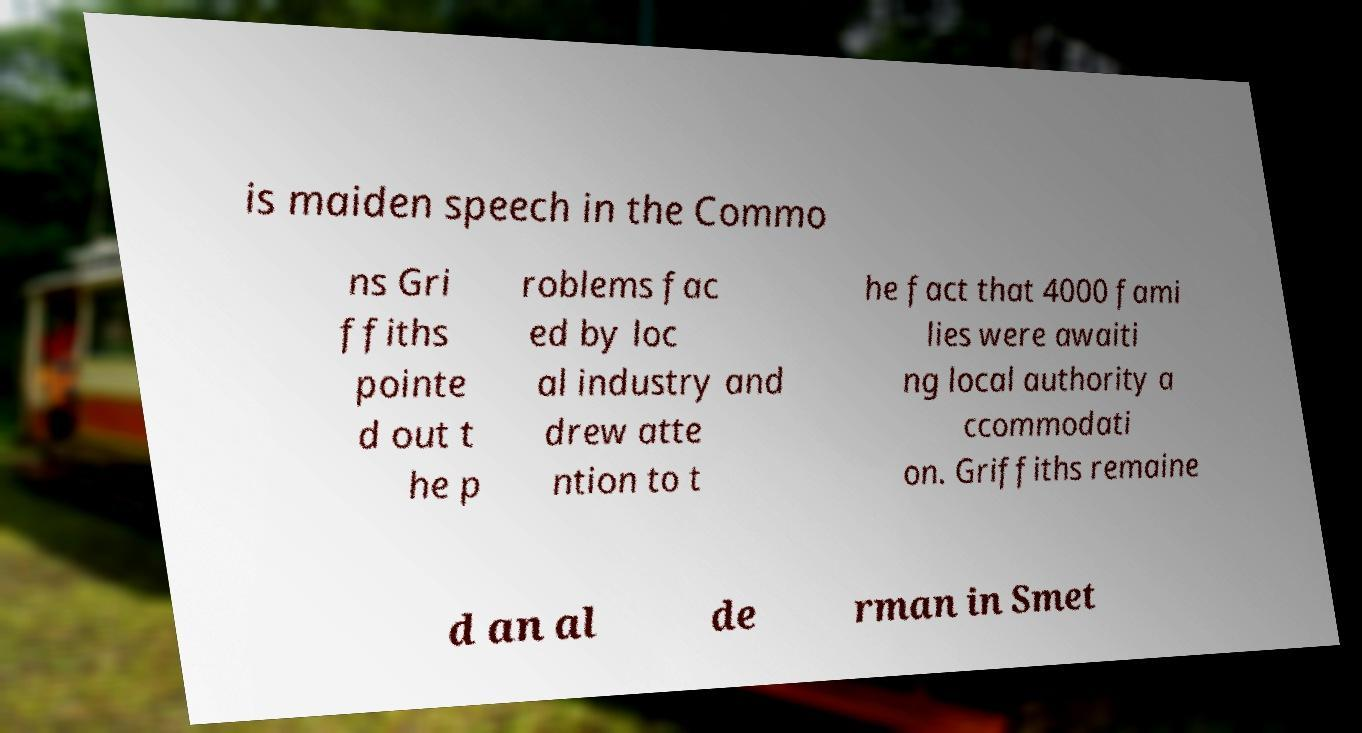Please read and relay the text visible in this image. What does it say? is maiden speech in the Commo ns Gri ffiths pointe d out t he p roblems fac ed by loc al industry and drew atte ntion to t he fact that 4000 fami lies were awaiti ng local authority a ccommodati on. Griffiths remaine d an al de rman in Smet 